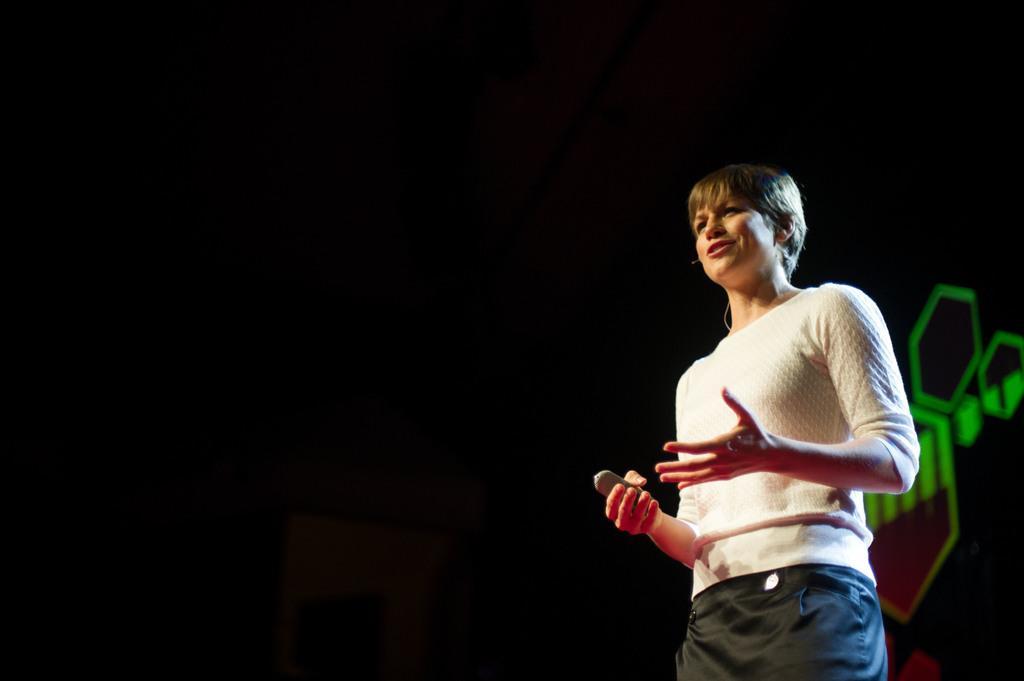In one or two sentences, can you explain what this image depicts? The woman in front of the picture wearing a white T-shirt is standing. She is holding something in her hands. She is talking on the microphone. Behind her, we see boards in red and green color. In the background, it is in black color. 